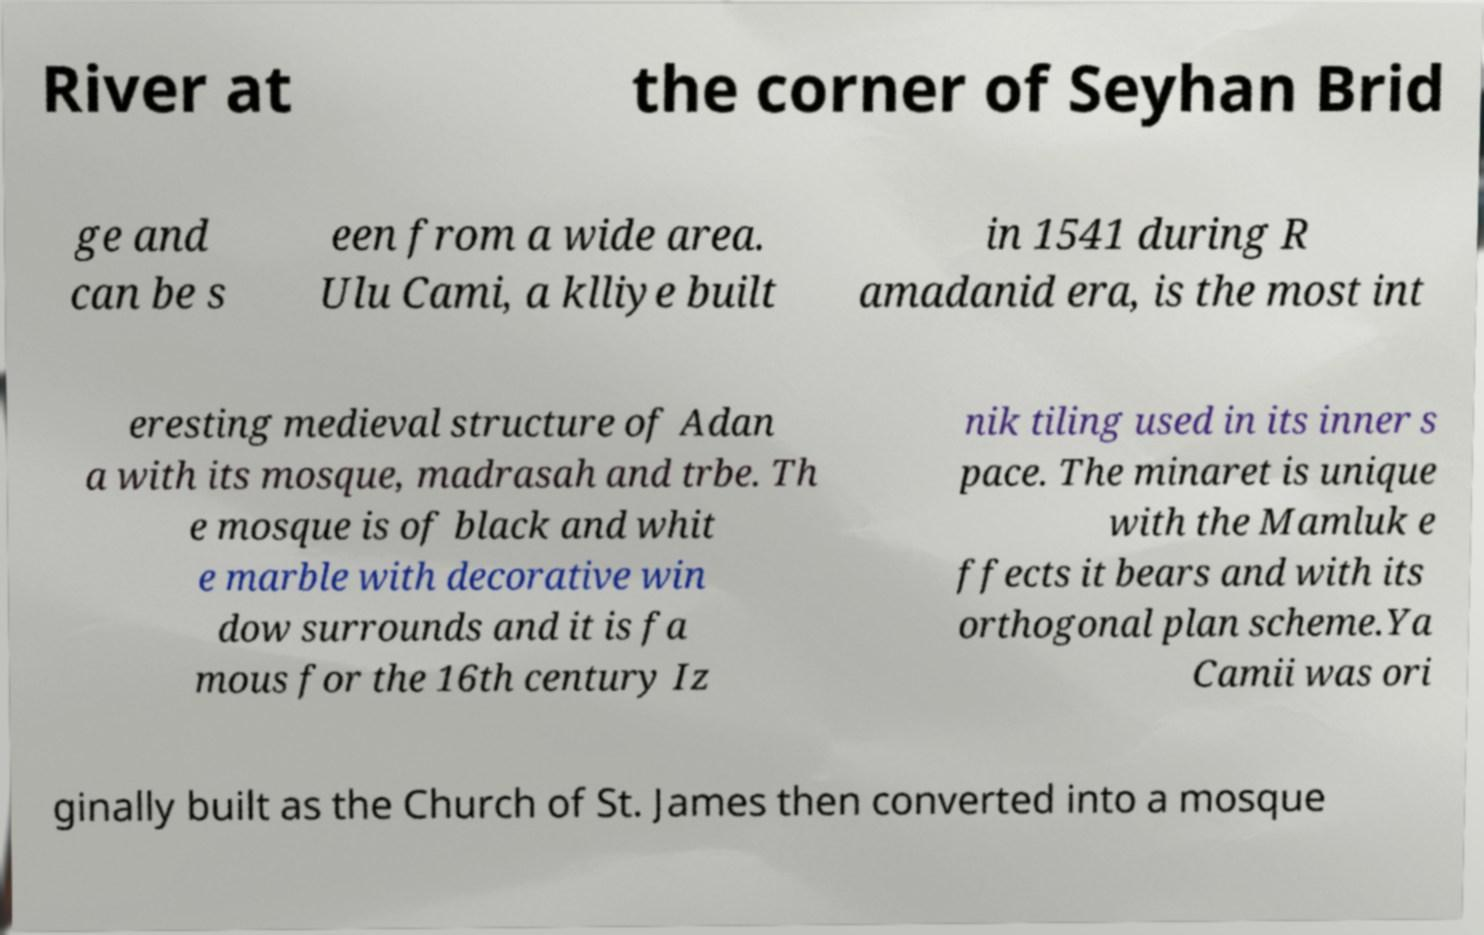Could you extract and type out the text from this image? River at the corner of Seyhan Brid ge and can be s een from a wide area. Ulu Cami, a klliye built in 1541 during R amadanid era, is the most int eresting medieval structure of Adan a with its mosque, madrasah and trbe. Th e mosque is of black and whit e marble with decorative win dow surrounds and it is fa mous for the 16th century Iz nik tiling used in its inner s pace. The minaret is unique with the Mamluk e ffects it bears and with its orthogonal plan scheme.Ya Camii was ori ginally built as the Church of St. James then converted into a mosque 